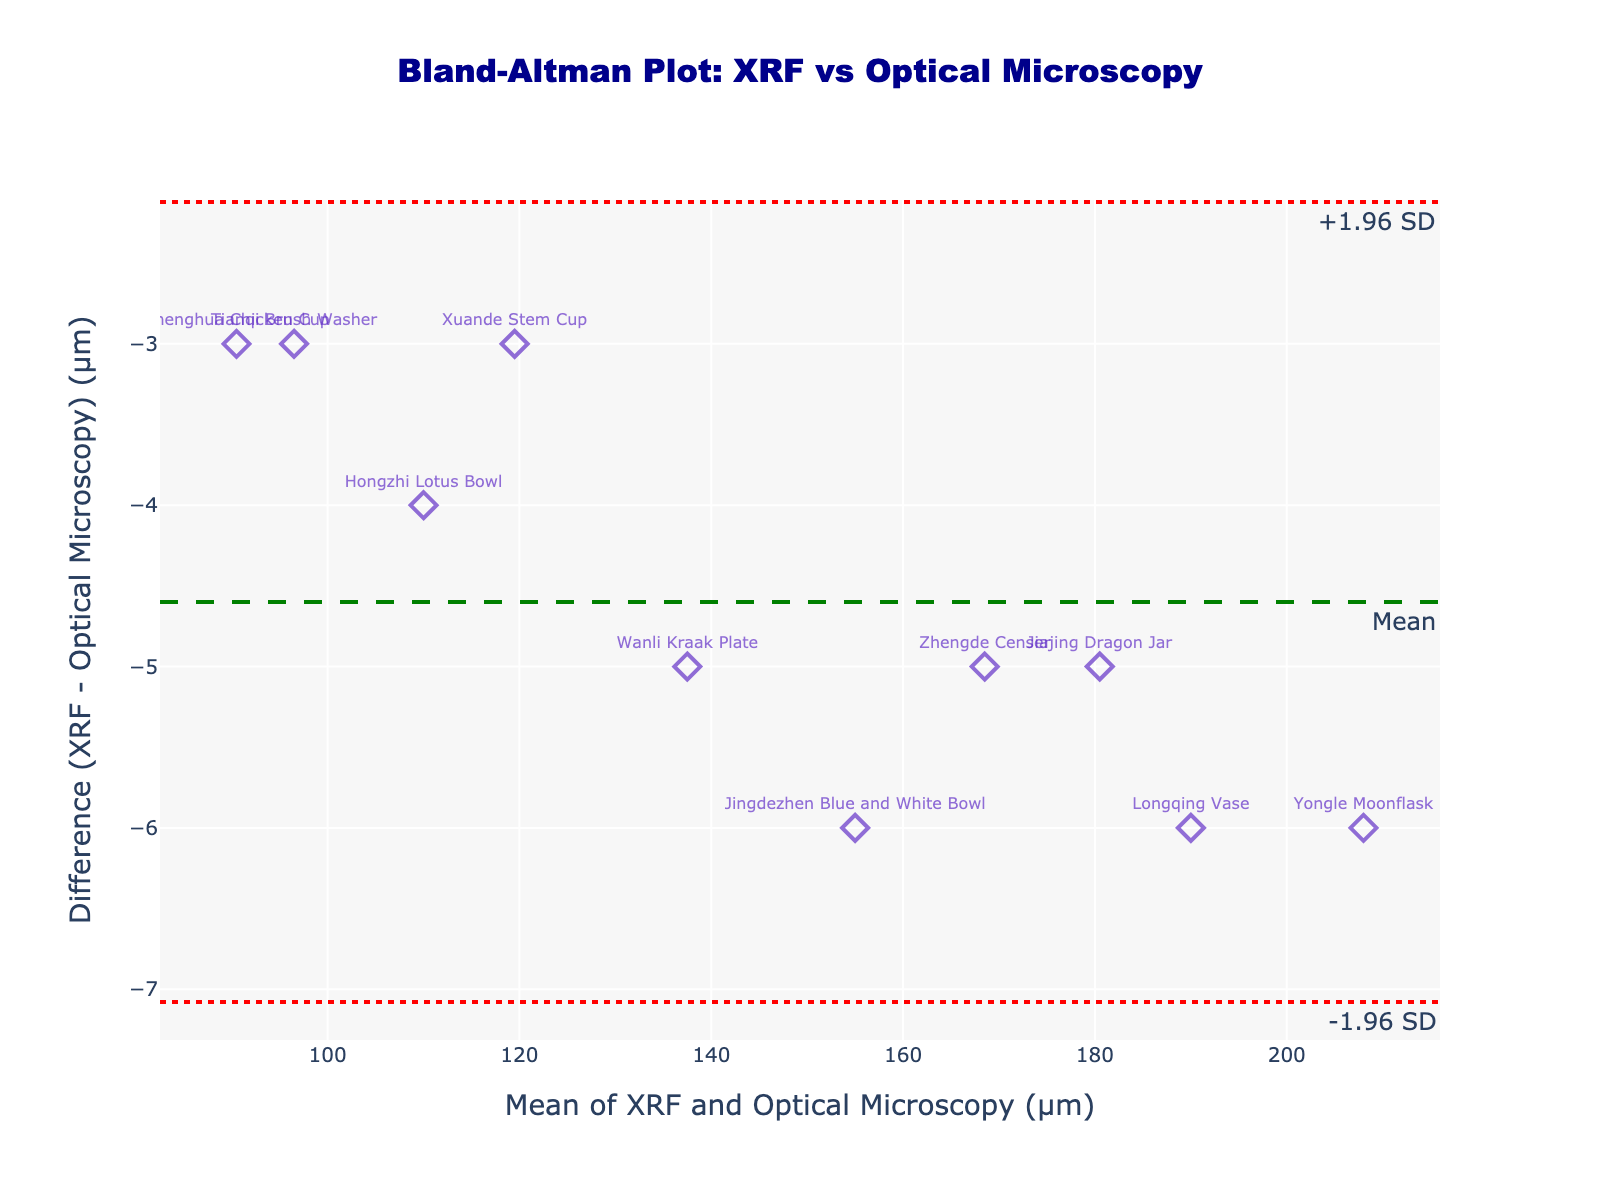What is the title of the Bland-Altman plot? The title of the plot is usually placed at the top center of the figure and is highlighted in a slightly larger and often bold font. In this case, it's specified clearly in the title section of the plot layout.
Answer: Bland-Altman Plot: XRF vs Optical Microscopy What is plotted on the x-axis? The x-axis typically represents the mean of the two measurement methods in a Bland-Altman plot. In the provided figure, it is labeled accordingly.
Answer: Mean of XRF and Optical Microscopy (µm) How many data points are shown in the plot? Each data point in the plot corresponds to an artifact measured by both methods. By counting the markers or examining the list of methods, we can determine the number.
Answer: 10 What is the mean difference between the two measurement methods? The mean difference is represented by the dashed green line. It is explicitly marked on the plot with a green dash line labeled "Mean".
Answer: ~-5.2 µm Which artifact has the largest positive difference? To find this, we observe the data points on the vertical (y-axis) that have the highest positive value. The associated text label provides the artifact name.
Answer: Jingdezhen Blue and White Bowl What is the range defined by the limits of agreement on the plot? The limits of agreement are marked by dotted red lines at +1.96 SD and -1.96 SD. These lines determine the range in which most differences should fall.
Answer: From ~-10.8 µm to ~0.4 µm What is the difference in measurements for the Wanli Kraak Plate? Locate the Wanli Kraak Plate on the scatter plot by finding its label, then read its corresponding y-value (difference between XRF and Optical Microscopy).
Answer: ~-5 µm How do the mean differences compare among Jingdezhen Blue and White Bowl, Chenghua Chicken Cup, and Longqing Vase? Locate each artifact on the plot by finding their labels, then compare their respective differences against each other.
Answer: Jingdezhen Blue and White Bowl: 6 µm, Chenghua Chicken Cup: 3 µm, Longqing Vase: 6 µm Which artifact has the smallest absolute difference between the two methods? Locate the data point closest to y = 0 (the horizontal axis) and identify the corresponding artifact from its label.
Answer: Chenghua Chicken Cup Is the range of the mean values between XRF and Optical Microscopy (µm) broader or narrower than the range of differences? Compare the spread of data points along the x-axis (mean values) to their spread along the y-axis (differences). The broader range will have more spread-out points.
Answer: Mean values range is broader 